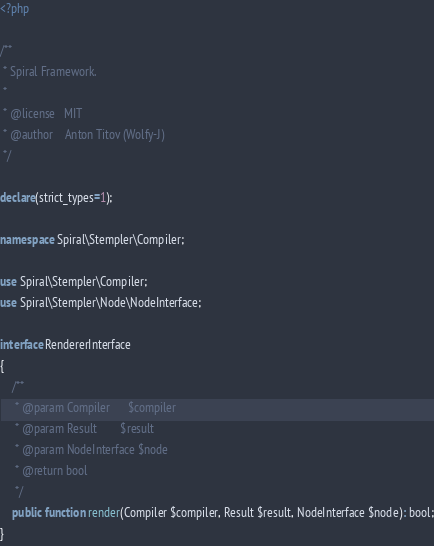Convert code to text. <code><loc_0><loc_0><loc_500><loc_500><_PHP_><?php

/**
 * Spiral Framework.
 *
 * @license   MIT
 * @author    Anton Titov (Wolfy-J)
 */

declare(strict_types=1);

namespace Spiral\Stempler\Compiler;

use Spiral\Stempler\Compiler;
use Spiral\Stempler\Node\NodeInterface;

interface RendererInterface
{
    /**
     * @param Compiler      $compiler
     * @param Result        $result
     * @param NodeInterface $node
     * @return bool
     */
    public function render(Compiler $compiler, Result $result, NodeInterface $node): bool;
}
</code> 